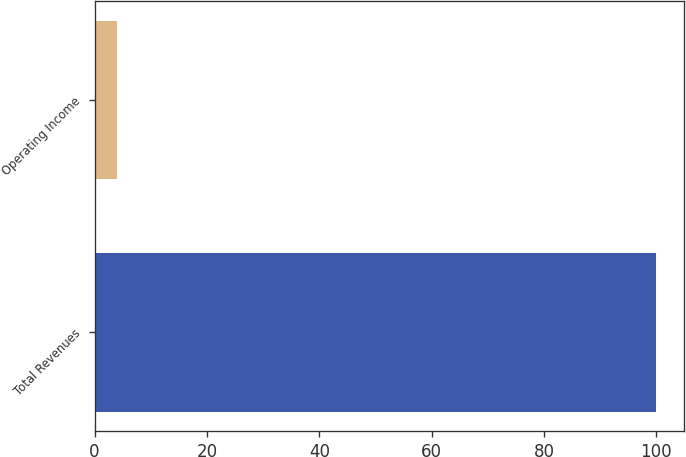Convert chart. <chart><loc_0><loc_0><loc_500><loc_500><bar_chart><fcel>Total Revenues<fcel>Operating Income<nl><fcel>100<fcel>4<nl></chart> 